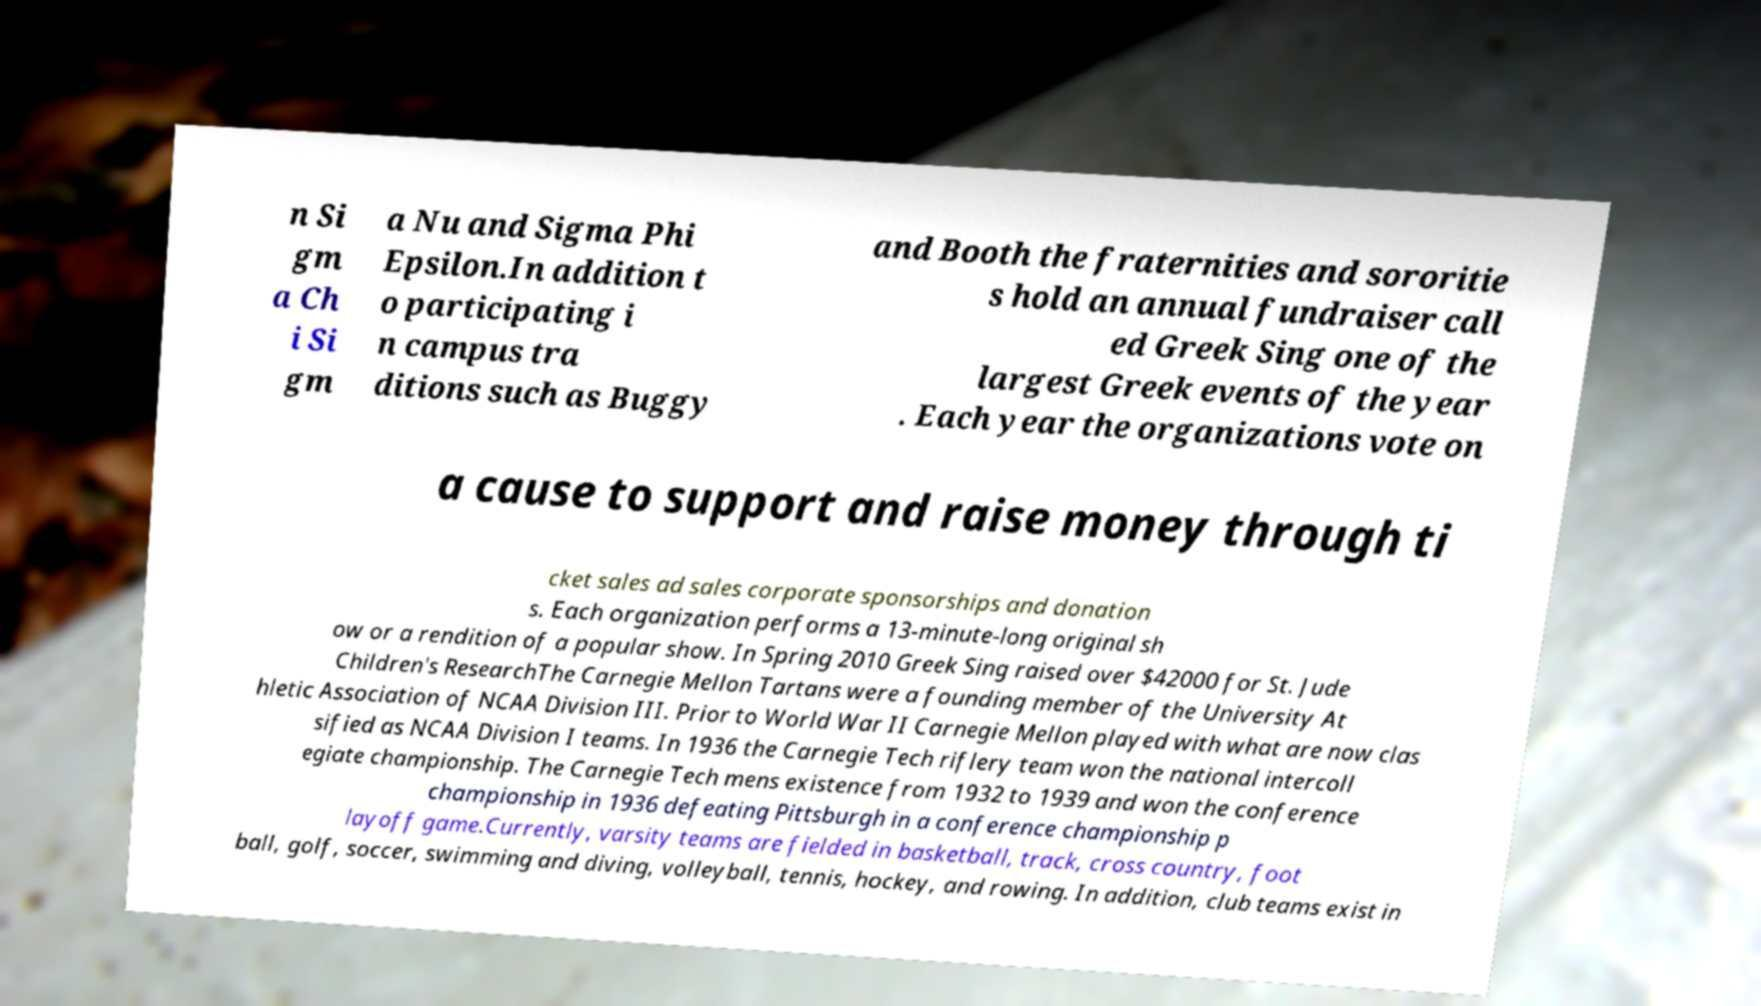There's text embedded in this image that I need extracted. Can you transcribe it verbatim? n Si gm a Ch i Si gm a Nu and Sigma Phi Epsilon.In addition t o participating i n campus tra ditions such as Buggy and Booth the fraternities and sororitie s hold an annual fundraiser call ed Greek Sing one of the largest Greek events of the year . Each year the organizations vote on a cause to support and raise money through ti cket sales ad sales corporate sponsorships and donation s. Each organization performs a 13-minute-long original sh ow or a rendition of a popular show. In Spring 2010 Greek Sing raised over $42000 for St. Jude Children's ResearchThe Carnegie Mellon Tartans were a founding member of the University At hletic Association of NCAA Division III. Prior to World War II Carnegie Mellon played with what are now clas sified as NCAA Division I teams. In 1936 the Carnegie Tech riflery team won the national intercoll egiate championship. The Carnegie Tech mens existence from 1932 to 1939 and won the conference championship in 1936 defeating Pittsburgh in a conference championship p layoff game.Currently, varsity teams are fielded in basketball, track, cross country, foot ball, golf, soccer, swimming and diving, volleyball, tennis, hockey, and rowing. In addition, club teams exist in 